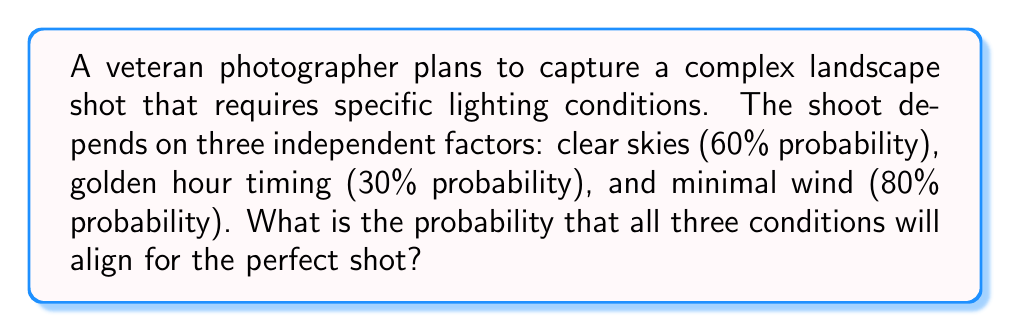Can you solve this math problem? To solve this problem, we'll use the multiplication rule of probability for independent events. Since all three conditions need to occur simultaneously, and they are independent of each other, we multiply their individual probabilities:

1. Probability of clear skies: $P(\text{clear}) = 0.60$
2. Probability of golden hour timing: $P(\text{golden}) = 0.30$
3. Probability of minimal wind: $P(\text{wind}) = 0.80$

The probability of all three conditions occurring together is:

$$P(\text{perfect shot}) = P(\text{clear}) \times P(\text{golden}) \times P(\text{wind})$$

Substituting the values:

$$P(\text{perfect shot}) = 0.60 \times 0.30 \times 0.80$$

Calculate:

$$P(\text{perfect shot}) = 0.144$$

To express this as a percentage:

$$P(\text{perfect shot}) = 0.144 \times 100\% = 14.4\%$$

Therefore, the probability of achieving optimal lighting conditions for the complex landscape shot is 14.4%.
Answer: 14.4% 